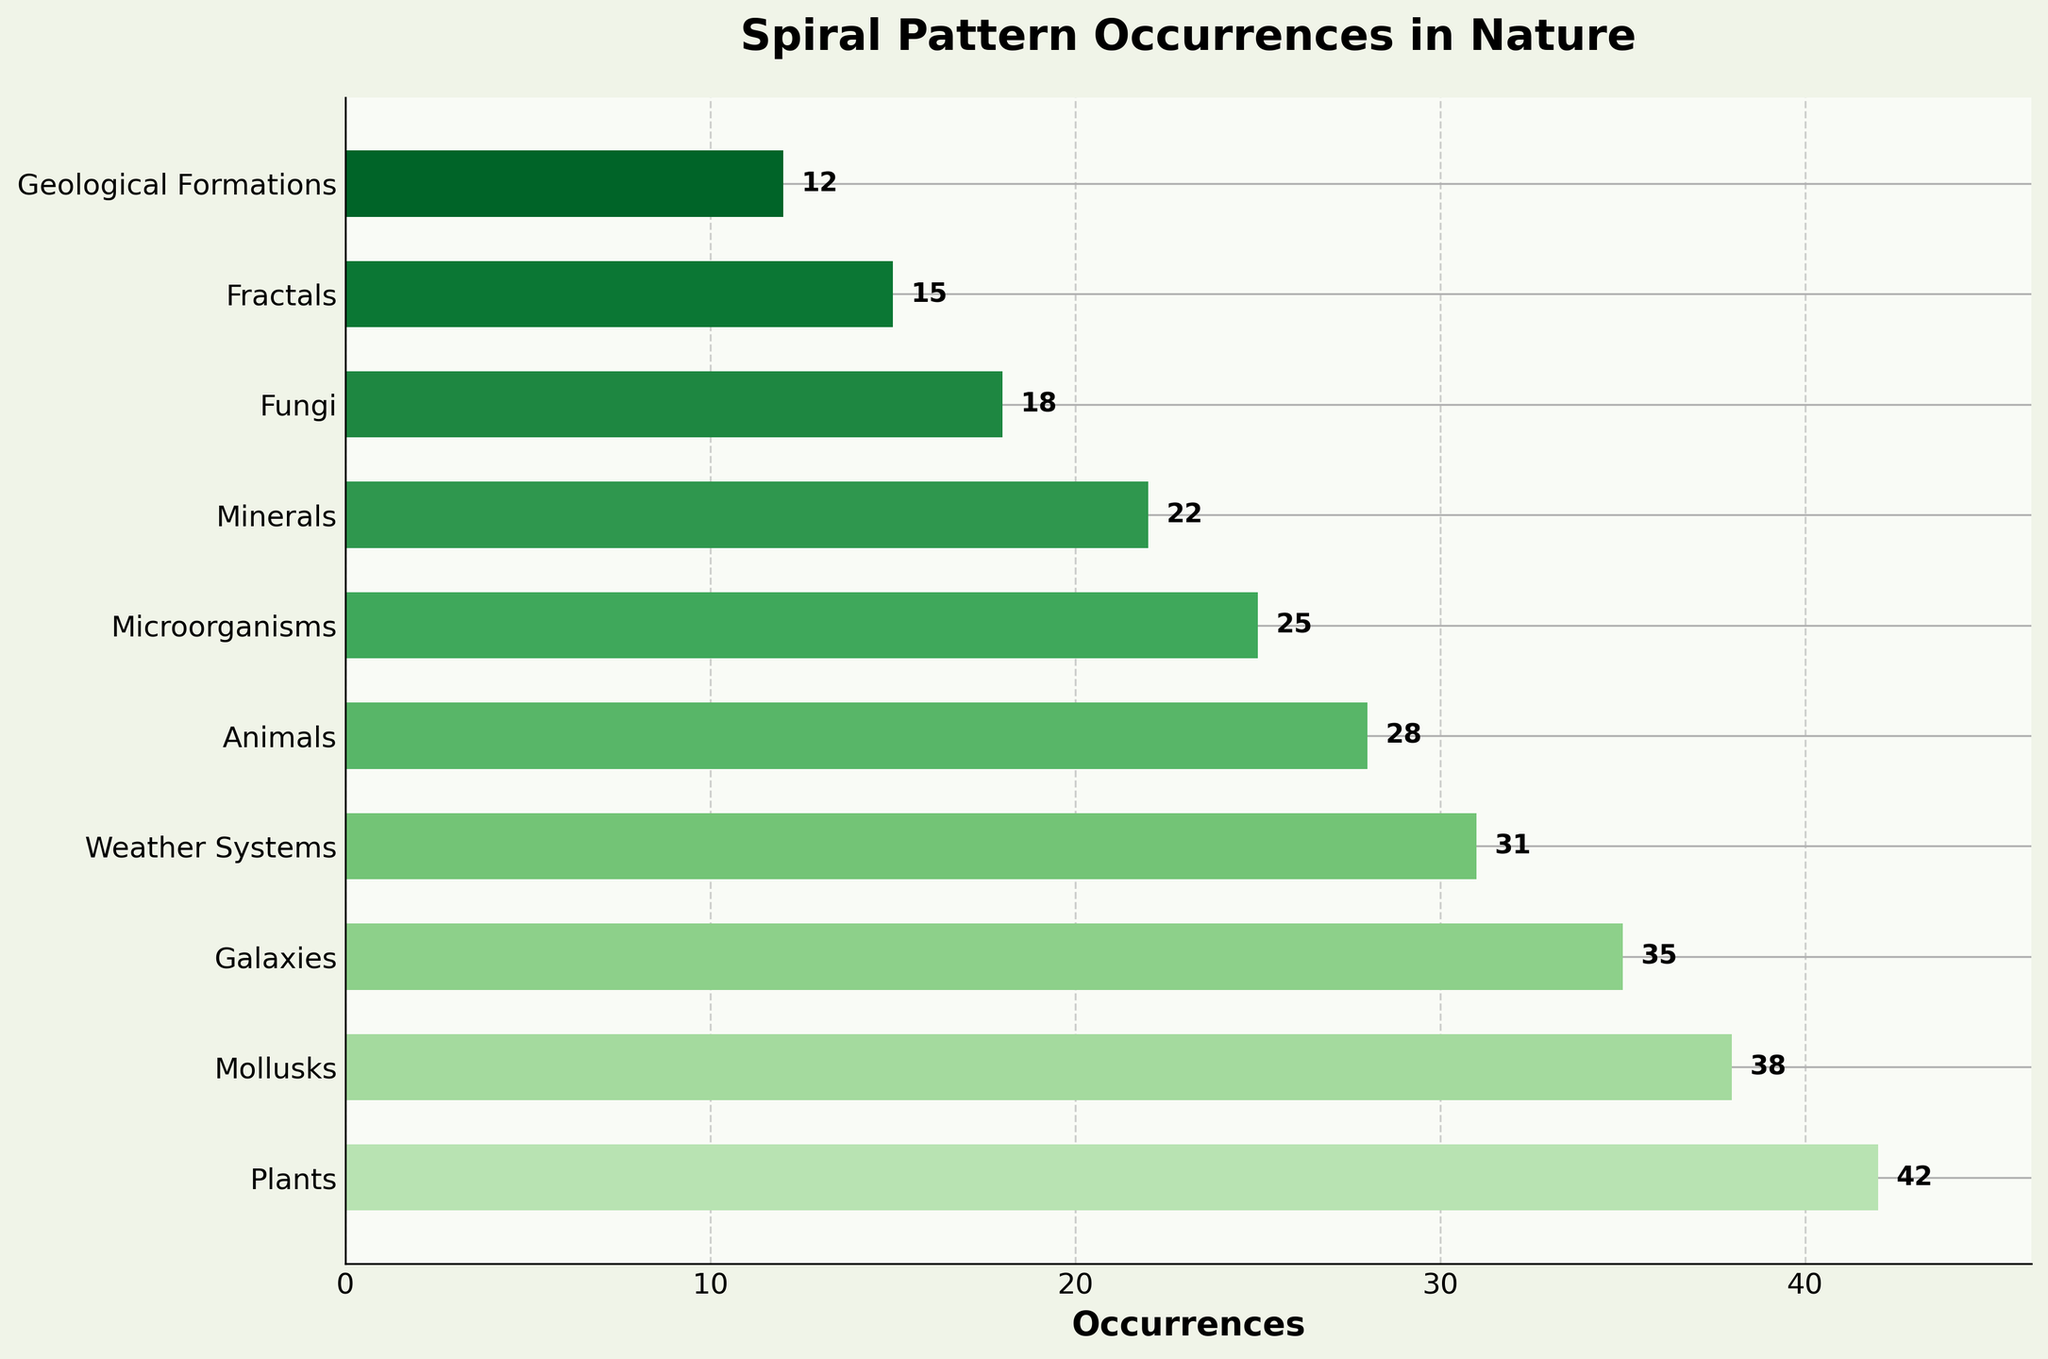Which organism type has the highest occurrence of spiral patterns? By looking at the bar chart, the bar corresponding to "Plants" reaches the highest value on the occurrences axis.
Answer: Plants Which organism type has the lowest occurrence of spiral patterns? The smallest bar, which is the lowest on the occurrences axis, corresponds to "Geological Formations".
Answer: Geological Formations How many more occurrences of spiral patterns are there in Mollusks compared to Microorganisms? First, find the occurrence values for Mollusks (38) and Microorganisms (25). Then subtract the latter from the former to find the difference: 38 - 25 = 13.
Answer: 13 Compare the occurrences of spiral patterns in Animals and Fractals. Which is higher, and by how much? The occurrence value for Animals is 28, and for Fractals, it is 15. Animals have 28 - 15 = 13 more occurrences than Fractals.
Answer: Animals, 13 What is the sum of the occurrences for Fungi, Fractals, and Geological Formations combined? Add the occurrence values for Fungi (18), Fractals (15), and Geological Formations (12): 18 + 15 + 12 = 45.
Answer: 45 What are the differences in occurrences between the top three organism types (Plants, Mollusks, Galaxies) and the bottom three (Minerals, Fungi, Fractals)? The top three values are for Plants (42), Mollusks (38), and Galaxies (35), while the bottom three are for Minerals (22), Fungi (18), and Fractals (15). Calculate the differences: Plants - Minerals = 42 - 22 = 20, Mollusks - Fungi = 38 - 18 = 20, Galaxies - Fractals = 35 - 15 = 20.
Answer: 20 Which categories have occurrences of spiral patterns between 20 and 30? Find bars with occurrence values within the specified range. These are Animals (28), Microorganisms (25), and Minerals (22).
Answer: Animals, Microorganisms, Minerals What's the average occurrence of spiral patterns across all the organism types listed? Add all occurrence values: 42 + 38 + 35 + 31 + 28 + 25 + 22 + 18 + 15 + 12 = 266. Then divide by the number of types (10): 266 / 10 = 26.6.
Answer: 26.6 How does the occurrence of spiral patterns in Weather Systems compare to that in Animals? Weather Systems have 31 occurrences, while Animals have 28. Therefore, Weather Systems have 31 - 28 = 3 more occurrences than Animals.
Answer: 3 more 